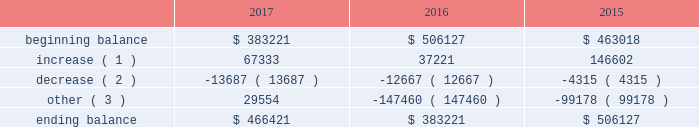The principal components of eog's rollforward of valuation allowances for deferred income tax assets were as follows ( in thousands ) : .
( 1 ) increase in valuation allowance related to the generation of tax nols and other deferred tax assets .
( 2 ) decrease in valuation allowance associated with adjustments to certain deferred tax assets and their related allowance .
( 3 ) represents dispositions/revisions/foreign exchange rate variances and the effect of statutory income tax rate changes .
As of december 31 , 2017 , eog had state income tax nols being carried forward of approximately $ 1.7 billion , which , if unused , expire between 2018 and 2036 .
During 2017 , eog's united kingdom subsidiary incurred a tax nol of approximately $ 72 million which , along with prior years' nols of $ 857 million , will be carried forward indefinitely .
Eog also has united states federal and canadian nols of $ 335 million and $ 158 million , respectively , with varying carryforward periods .
Eog's remaining amt credits total $ 798 million , resulting from amt paid with respect to prior years and an increase of $ 41 million in 2017 .
As described above , these nols and credits , as well as other less significant future income tax benefits , have been evaluated for the likelihood of utilization , and valuation allowances have been established for the portion of these deferred income tax assets that t do not meet the "more likely than not" threshold .
As further described above , significant changes were made by the tcja to the corporate amt that are favorable to eog , including the refunding of amt credit carryovers .
Due to these legislative changes , eog intends to settle certain uncertain tax positions related to amt credits for taxable years 2011 through 2015 , resulting in a decrease of uncertain tax positions of $ 40 million .
The amount of unrecognized tax benefits at december 31 , 2017 , was $ 39 million , resulting from the tax treatment of its research and experimental expenditures related to certain innovations in its horizontal drilling and completion projects , which ish not expected to have an earnings impact .
Eog records interest and penalties related to unrecognized tax benefits to its income tax provision .
Eog does not anticipate that the amount of the unrecognized tax benefits will increase during the next twelve months .
Eog and its subsidiaries file income tax returns and are subject to tax audits in the united states and various state , local and foreign jurisdictions .
Eog's earliest open tax years in its principal jurisdictions are as follows : united states federal ( 2011 ) , canada ( 2014 ) , united kingdom ( 2016 ) , trinidad ( 2011 ) and china ( 2008 ) .
Eog's foreign subsidiaries' undistributed earnings are no longer considered to be permanently reinvested outside the u.s .
And , accordingly , eog has cumulatively recorded $ 20 million of foreign and state deferred income taxes as of december 31 , 2017 .
Employee benefit plans stock-based compensation during 2017 , eog maintained various stock-based compensation plans as discussed below .
Eog recognizes compensation expense on grants of stock options , sars , restricted stock and restricted stock units , performance units and grants made under the eog resources , inc .
Employee stock purchase plan ( espp ) .
Stock-based compensation expense is calculated based upon the grant date estimated fair value of the awards , net of forfeitures , based upon eog's historical employee turnover rate .
Compensation expense is amortized over the shorter of the vesting period or the period from date of grant until the date the employee becomes eligible to retire without company approval. .
Considering the eog's roll forward of valuation allowances for deferred income tax assets during 2015-2017 , what was the highest value registered in the beginning balance? 
Rationale: it is the maximum value of this period .
Computations: table_max(beginning balance, none)
Answer: 506127.0. 